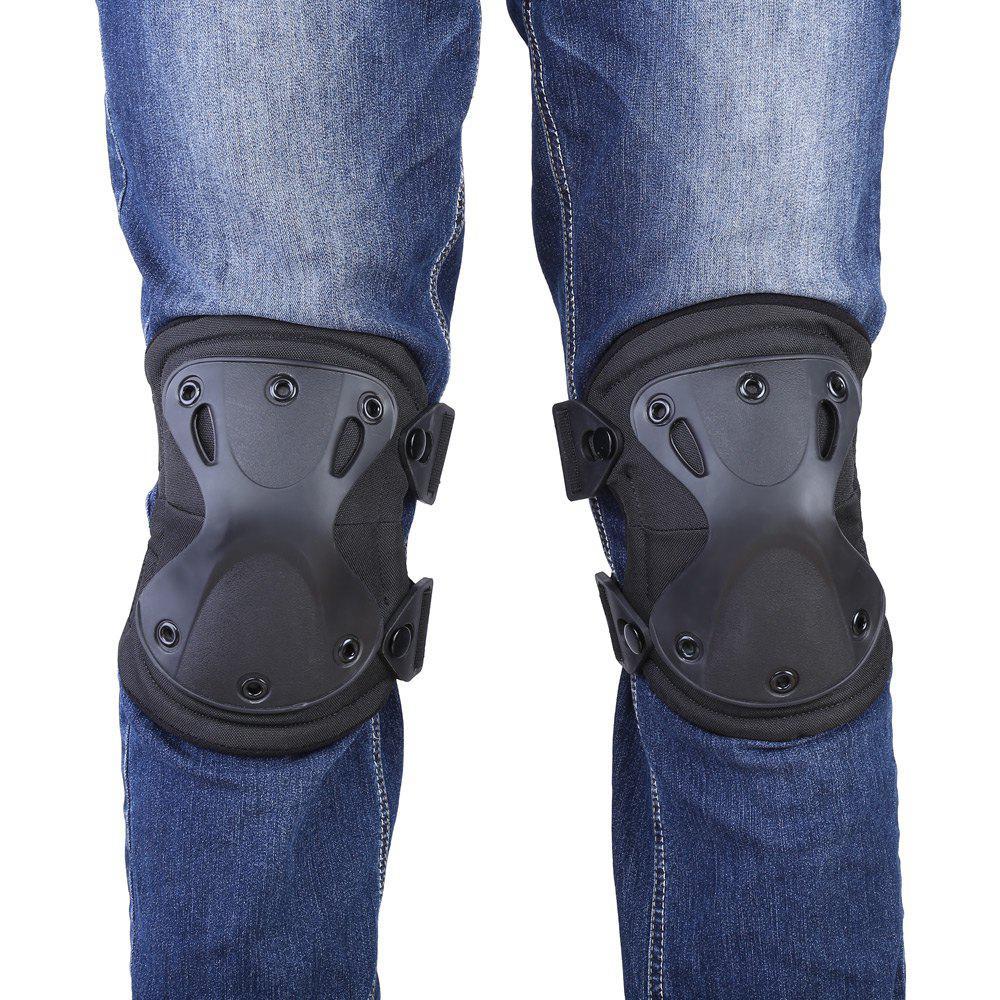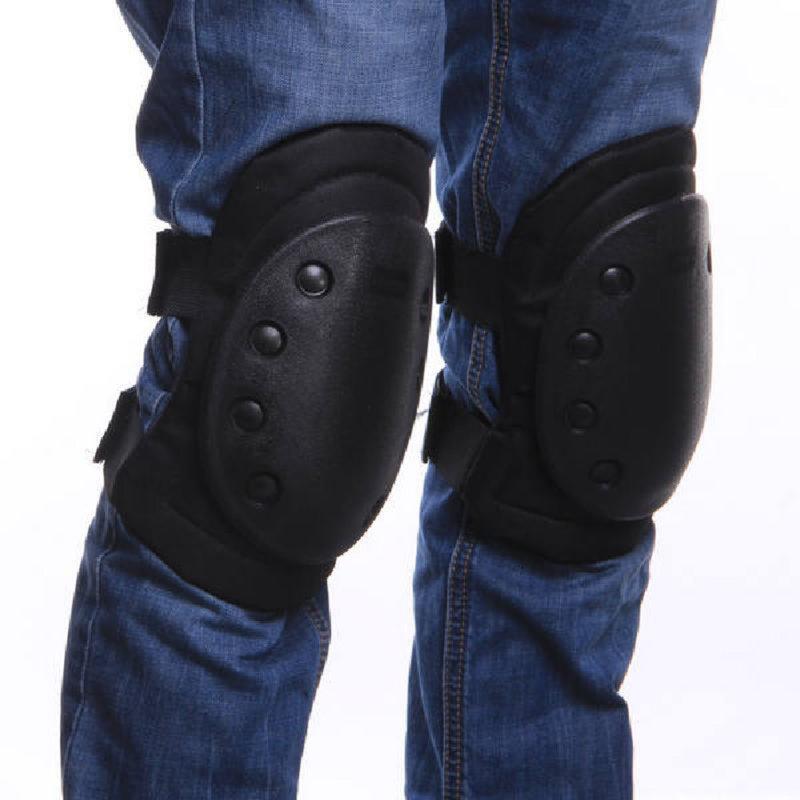The first image is the image on the left, the second image is the image on the right. Examine the images to the left and right. Is the description "Two sets of kneepads are shown as they fit on legs over jeans." accurate? Answer yes or no. Yes. The first image is the image on the left, the second image is the image on the right. Given the left and right images, does the statement "Both images show knee pads worn over denim jeans." hold true? Answer yes or no. Yes. 